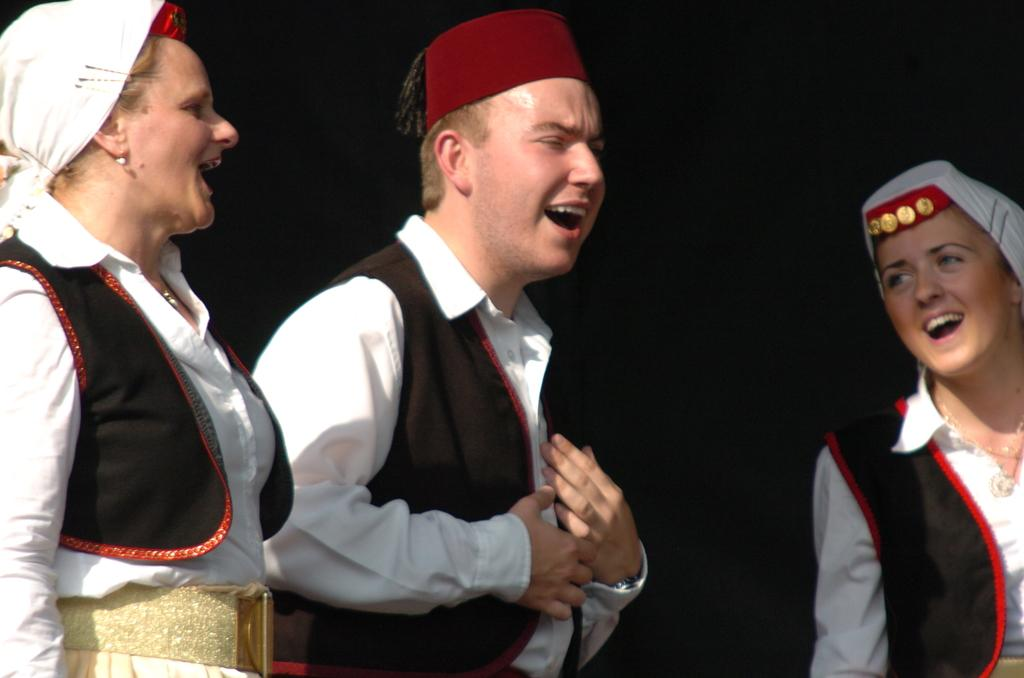Who or what can be seen in the foreground of the picture? There are people in the foreground of the picture. What are the people wearing? The people are wearing the same costumes. What are the people doing in the picture? The people are singing. What can be observed about the background of the image? The background of the image is dark. How many tests are being conducted by the army in the image? There is no army or test present in the image; it features people singing in the foreground with a dark background. 